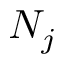Convert formula to latex. <formula><loc_0><loc_0><loc_500><loc_500>N _ { j }</formula> 